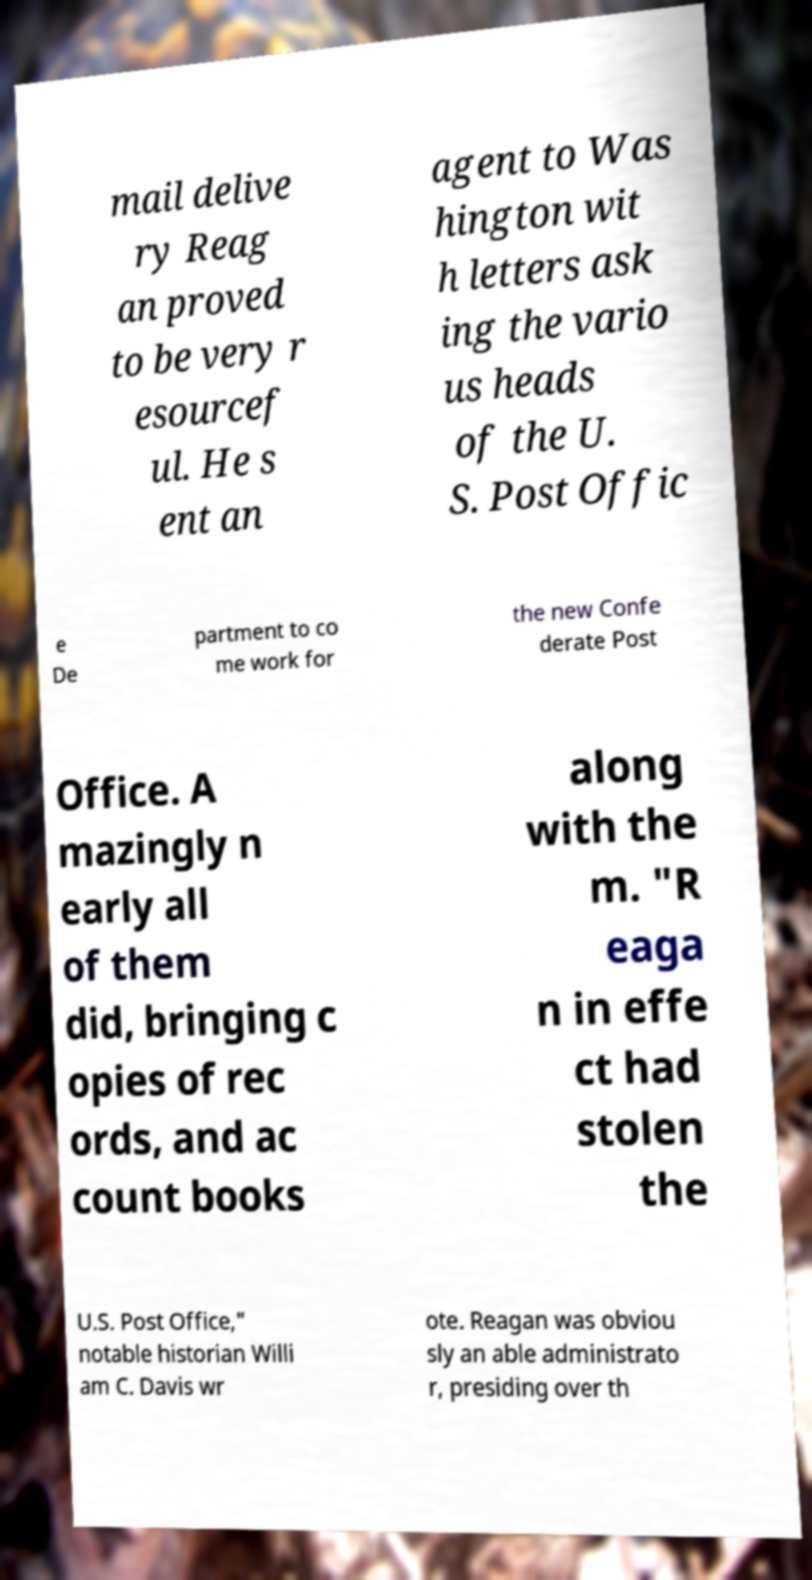Please read and relay the text visible in this image. What does it say? mail delive ry Reag an proved to be very r esourcef ul. He s ent an agent to Was hington wit h letters ask ing the vario us heads of the U. S. Post Offic e De partment to co me work for the new Confe derate Post Office. A mazingly n early all of them did, bringing c opies of rec ords, and ac count books along with the m. "R eaga n in effe ct had stolen the U.S. Post Office," notable historian Willi am C. Davis wr ote. Reagan was obviou sly an able administrato r, presiding over th 